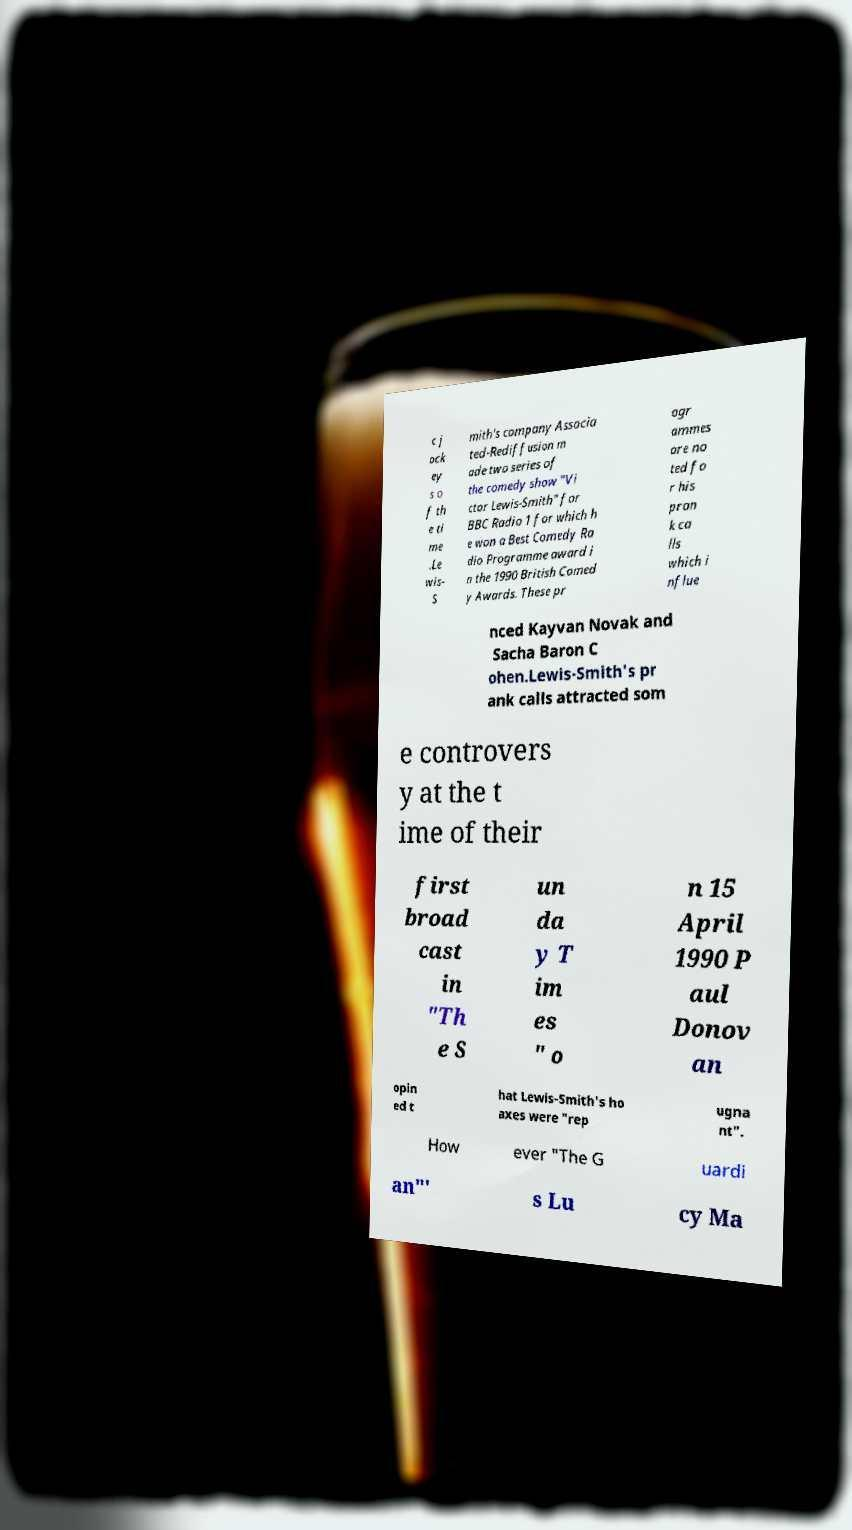Please read and relay the text visible in this image. What does it say? c j ock ey s o f th e ti me .Le wis- S mith's company Associa ted-Rediffusion m ade two series of the comedy show "Vi ctor Lewis-Smith" for BBC Radio 1 for which h e won a Best Comedy Ra dio Programme award i n the 1990 British Comed y Awards. These pr ogr ammes are no ted fo r his pran k ca lls which i nflue nced Kayvan Novak and Sacha Baron C ohen.Lewis-Smith's pr ank calls attracted som e controvers y at the t ime of their first broad cast in "Th e S un da y T im es " o n 15 April 1990 P aul Donov an opin ed t hat Lewis-Smith's ho axes were "rep ugna nt". How ever "The G uardi an"' s Lu cy Ma 